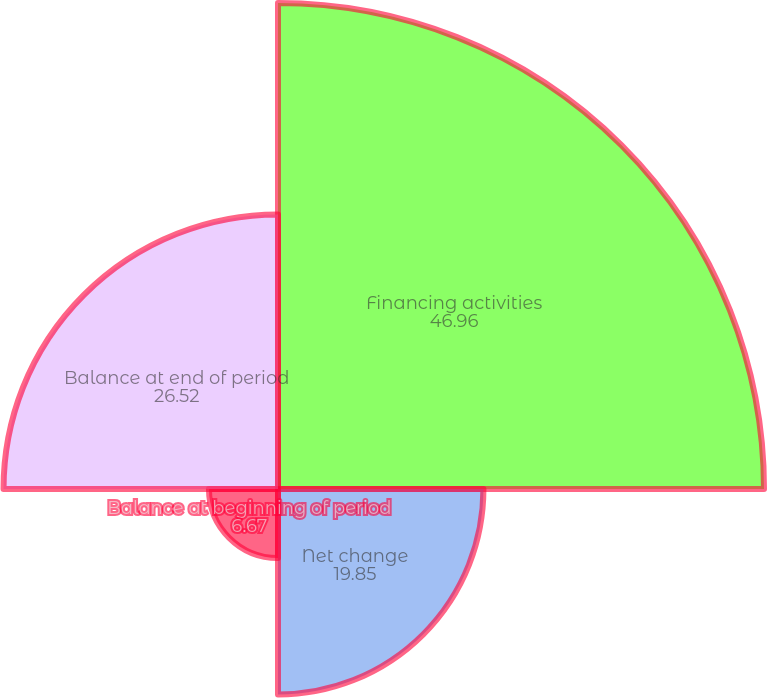<chart> <loc_0><loc_0><loc_500><loc_500><pie_chart><fcel>Financing activities<fcel>Net change<fcel>Balance at beginning of period<fcel>Balance at end of period<nl><fcel>46.96%<fcel>19.85%<fcel>6.67%<fcel>26.52%<nl></chart> 